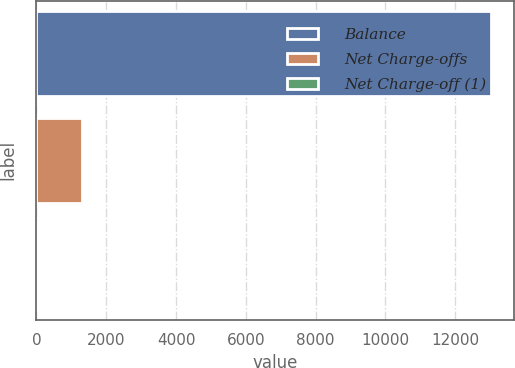Convert chart to OTSL. <chart><loc_0><loc_0><loc_500><loc_500><bar_chart><fcel>Balance<fcel>Net Charge-offs<fcel>Net Charge-off (1)<nl><fcel>13021<fcel>1304.27<fcel>2.41<nl></chart> 